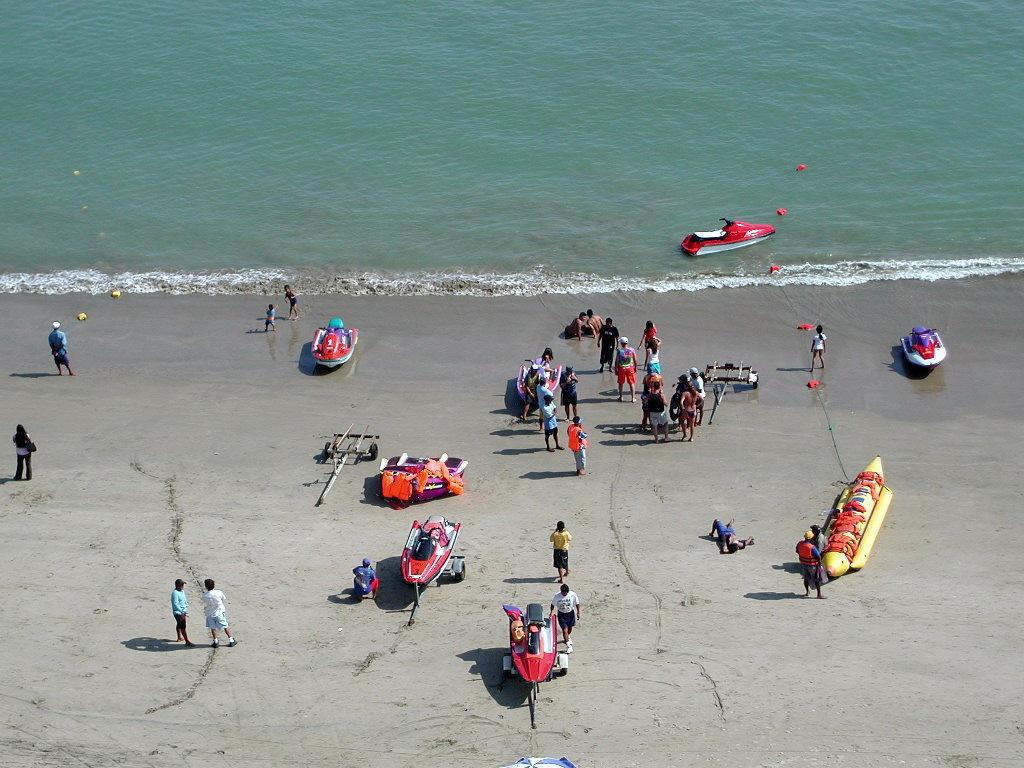Could you give a brief overview of what you see in this image? This picture is clicked outside the city. In the foreground we can see the speed boats and we can see the jet skis placed on the ground and we can see the group of persons. In the background there is a jet ski in the water body. 